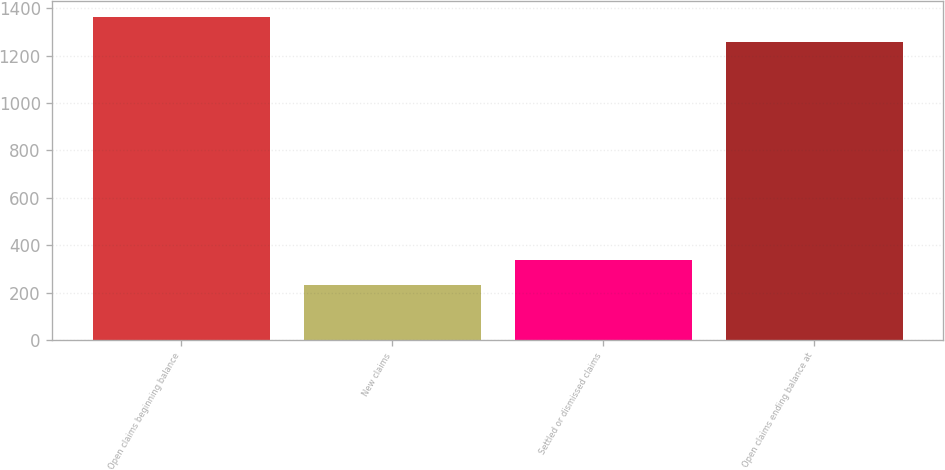Convert chart. <chart><loc_0><loc_0><loc_500><loc_500><bar_chart><fcel>Open claims beginning balance<fcel>New claims<fcel>Settled or dismissed claims<fcel>Open claims ending balance at<nl><fcel>1363.8<fcel>233<fcel>338.8<fcel>1258<nl></chart> 